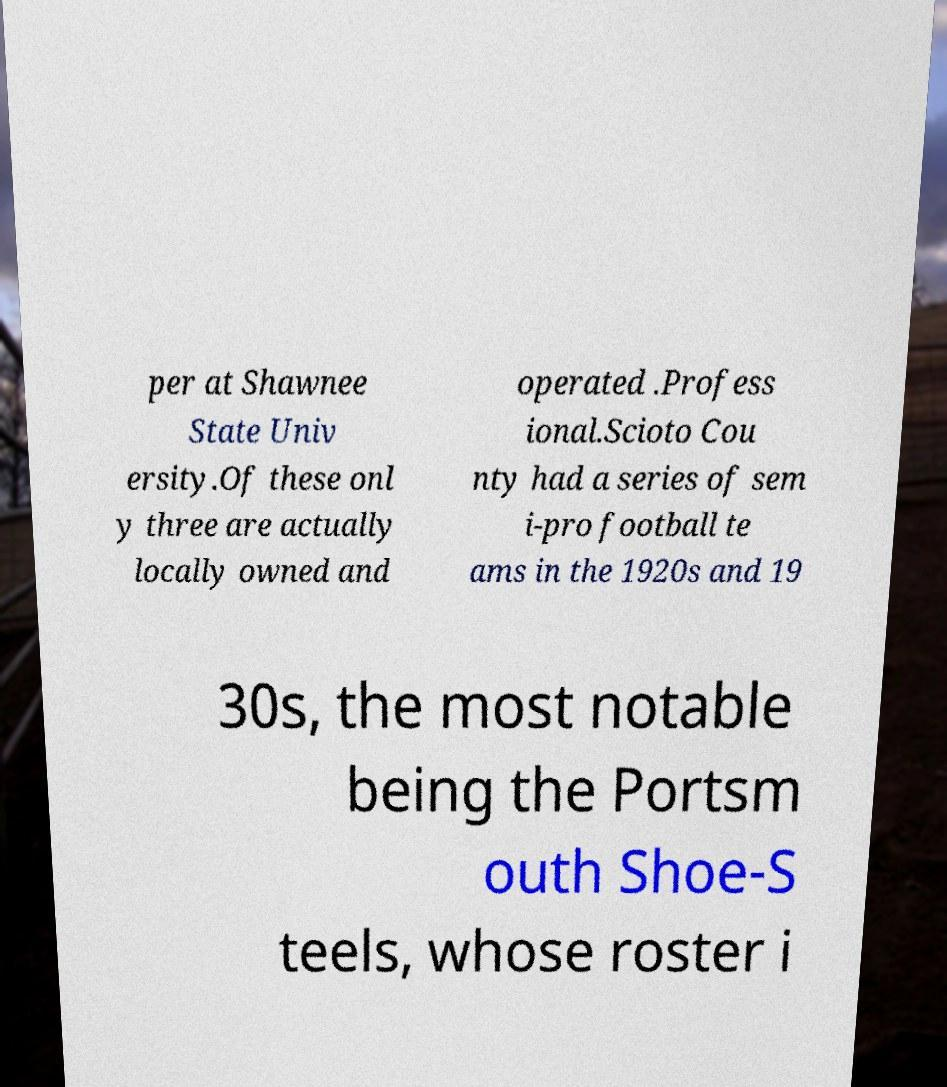For documentation purposes, I need the text within this image transcribed. Could you provide that? per at Shawnee State Univ ersity.Of these onl y three are actually locally owned and operated .Profess ional.Scioto Cou nty had a series of sem i-pro football te ams in the 1920s and 19 30s, the most notable being the Portsm outh Shoe-S teels, whose roster i 